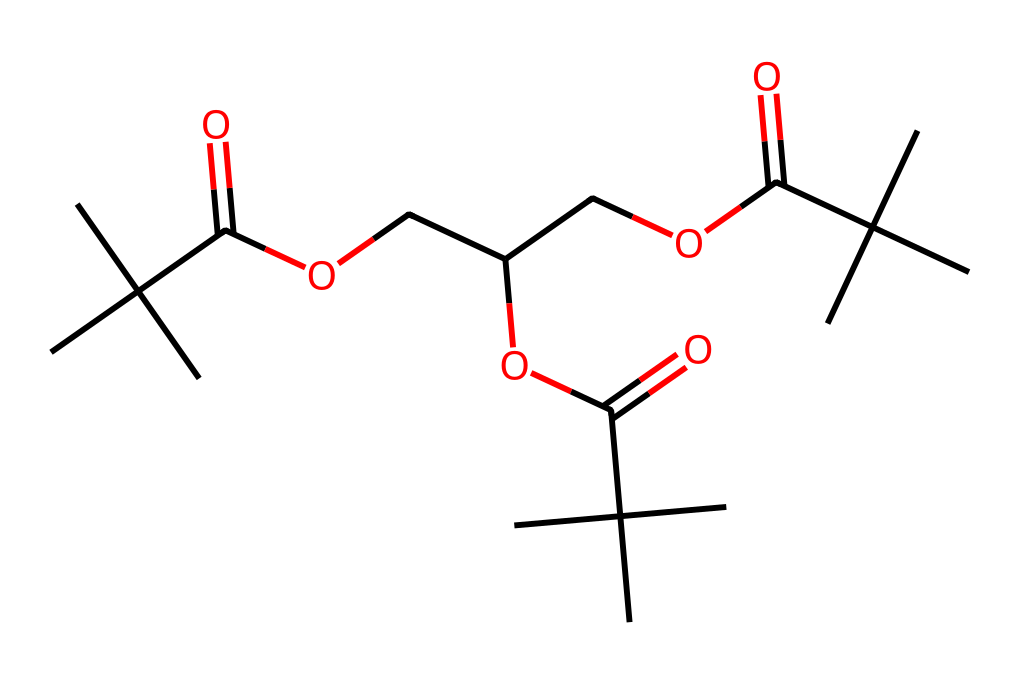what is the primary functional group present in this chemical? The structure contains several esters indicated by the presence of carbonyl groups (C=O) attached to oxygen atoms (O) within the molecule. This characteristic is typical of ester functional groups.
Answer: ester how many carbon atoms are present in this molecule? By analyzing the SMILES representation, the total number of carbon atoms can be counted directly from the structure. Counting yields a total of 18 carbon atoms.
Answer: 18 what type of polymerization is likely involved in creating acrylic polymers from this chemical structure? Acrylic polymers typically polymerize through addition polymerization due to the presence of double bonds and functional groups capable of chain growth. In this structure, the connectivity and functional groups suggest a pathway for such polymerization.
Answer: addition which aspect of this chemical contributes to its lubricating properties? The presence of long carbon chains and ester linkages in the molecule contributes to its lubricating properties by providing good shear stability and low friction characteristics when used in lubricants.
Answer: ester linkages how does the branching in this molecule affect its molecular interactions? The branching increases the viscosity and lowers the volatility of the molecule, which enhances its effectiveness as a lubricant by promoting smoother interactions between surfaces and reducing evaporation.
Answer: viscosity what is the role of the hydroxyl groups in this chemical structure? Hydroxyl groups contribute to the hydrophilicity of the chemical, improving adhesion properties in paint formulations and affecting the interaction with water and other polar solvents.
Answer: adhesion properties what is the likely application of this chemical in modern paint formulations? Given its structure, this chemical is likely used as a surfactant or emulsifier in paint formulations, enhancing the stability and uniformity of the paint mixture.
Answer: surfactant 